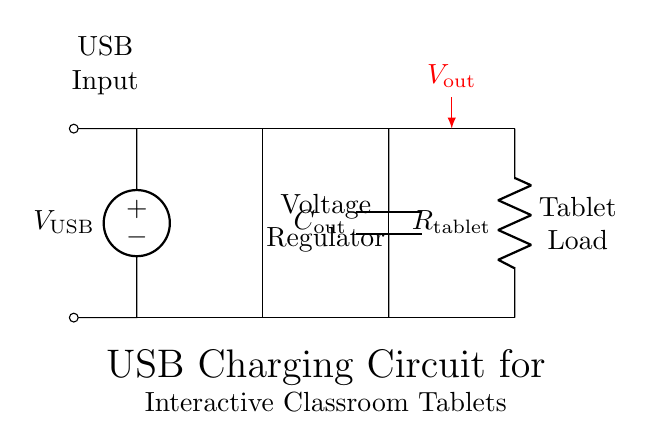What is the input voltage source? The circuit diagram indicates a voltage source labeled as V_USB, which represents the input voltage for the USB charging circuit.
Answer: V_USB What component regulates the voltage? The diagram shows a rectangle labeled as Voltage Regulator, which is responsible for regulating the output voltage to the desired level for the connected device.
Answer: Voltage Regulator What is the purpose of the output capacitor? In charging circuits, output capacitors are used to smooth the output voltage and provide stability by reducing voltage fluctuations, ensuring consistent power delivery to the load.
Answer: Smoothing output voltage Which component represents the tablet load? The circuit features a resistor labeled as R_tablet, which represents the load of the tablet being charged and consumes current from the power supply.
Answer: R_tablet What is the output voltage shown in the circuit? The output voltage is indicated with an arrow pointing to V_out, which refers to the regulated voltage supplied to the tablet load when everything is operating correctly.
Answer: V_out Why is the voltage regulator necessary in this circuit? The voltage regulator is essential because it ensures that the output voltage remains stable and at the proper level required by the tablet, preventing damage from overvoltage or unstable power supply.
Answer: To stabilize output voltage How is the tablet expected to connect in this circuit? The tablet is connected in parallel with the output of the voltage regulator, which allows it to draw the needed current through R_tablet while maintaining the regulated output voltage.
Answer: In parallel with the output 